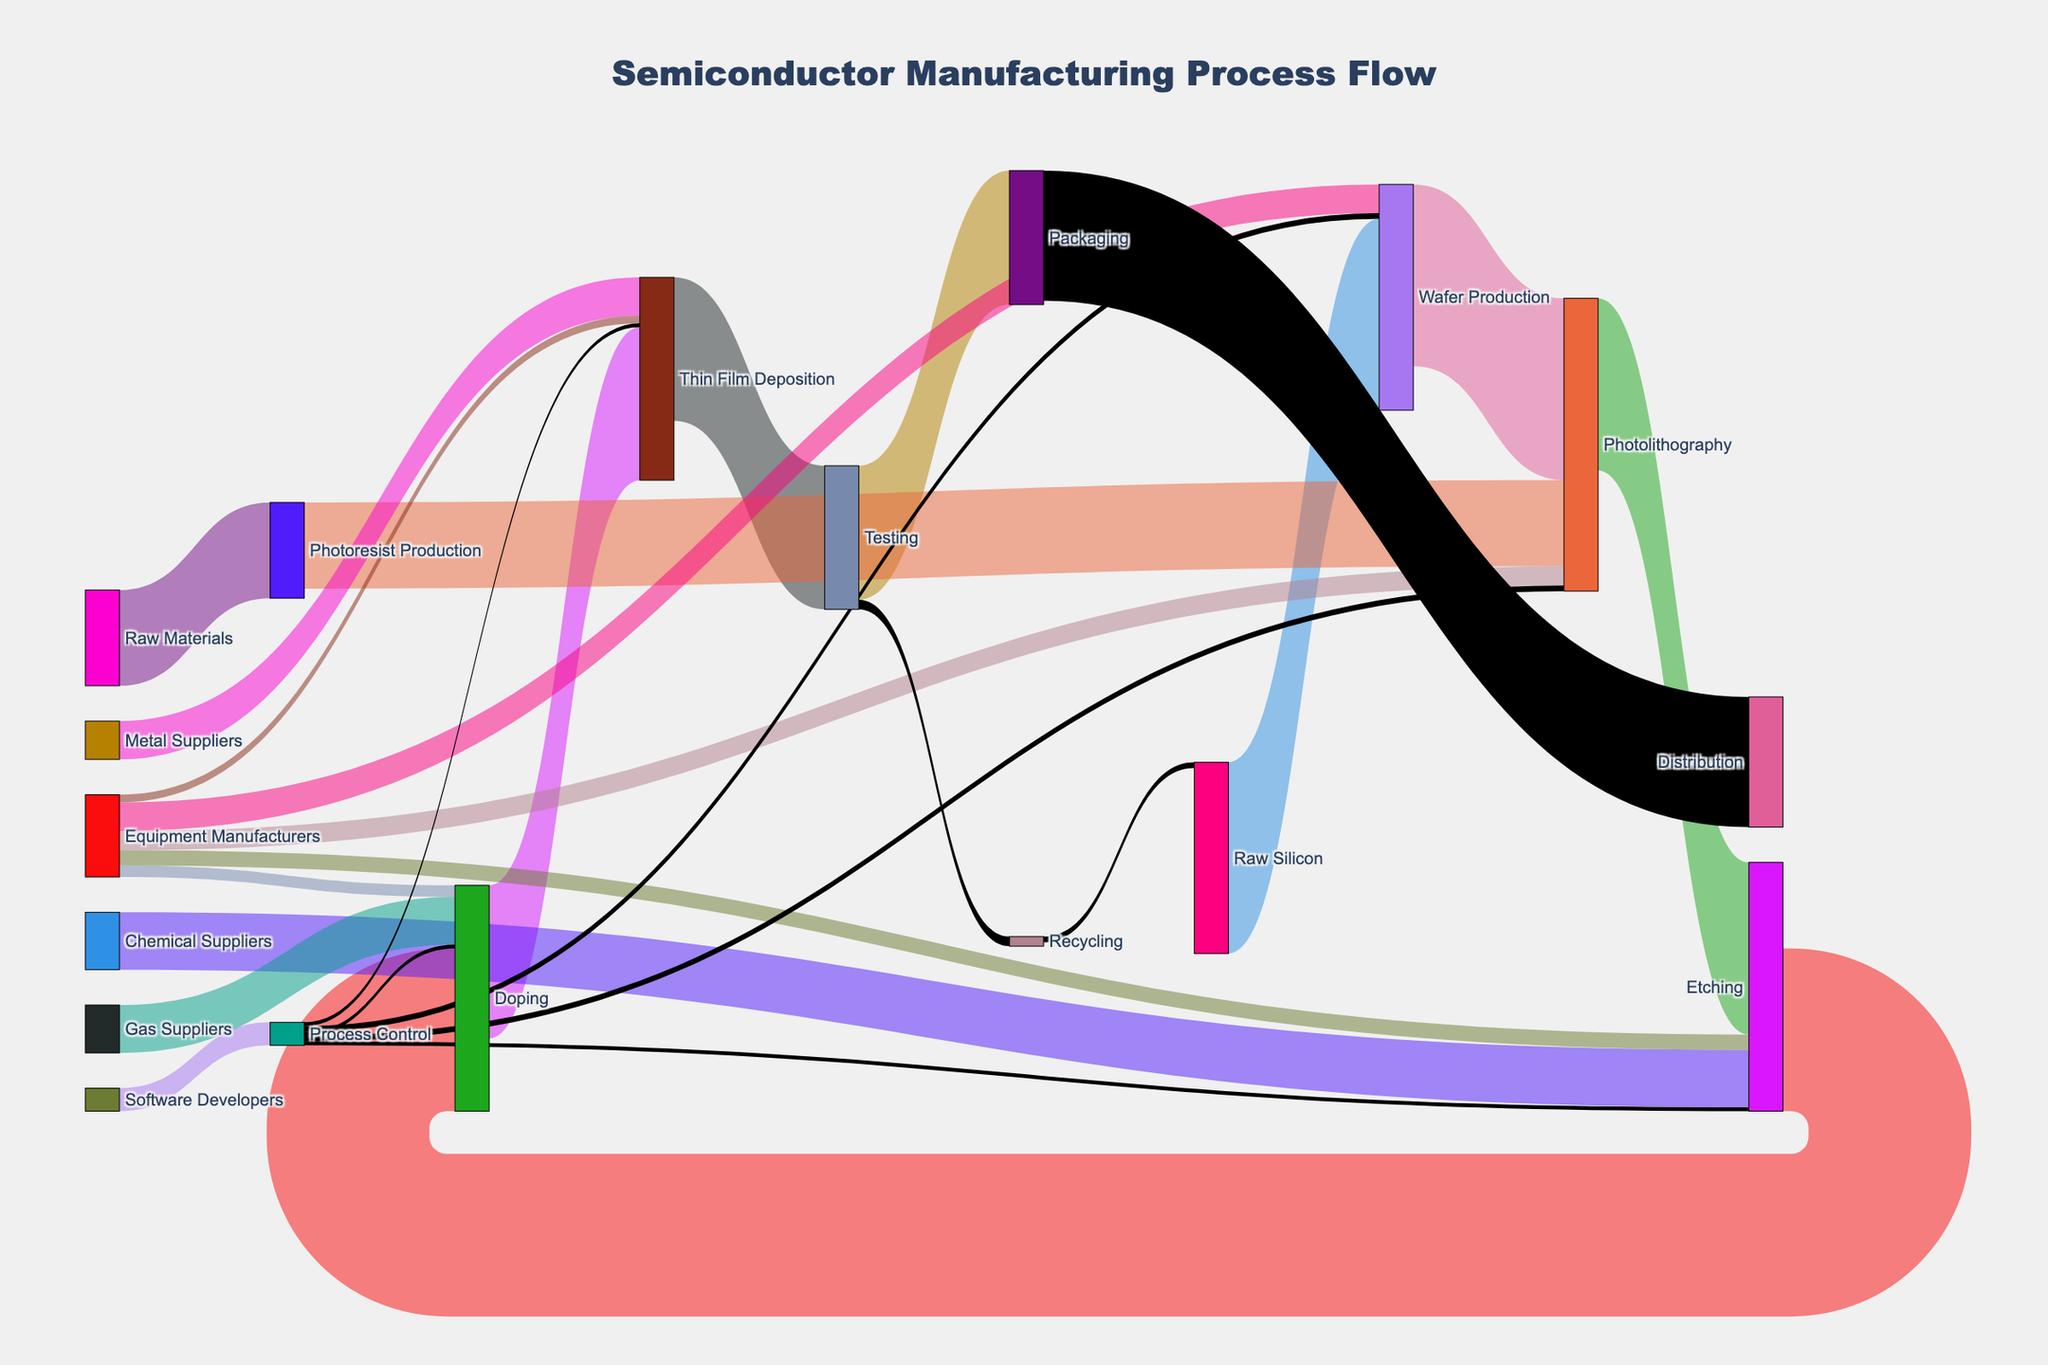What is the title of the Sankey Diagram? The diagram's title is often at the top and includes the subject matter. The title for this Sankey Diagram is provided in the code.
Answer: Semiconductor Manufacturing Process Flow Which node has the highest initial value? The node with the highest initial value is identified by the greatest number in the dataset's 'value' column under the 'source' category. The value 100 is associated with 'Raw Silicon'.
Answer: Raw Silicon How many paths lead directly from Equipment Manufacturers? Count the number of connections, or 'links', that start from 'Equipment Manufacturers' in the source column. There are links to Wafer Production, Photolithography, Etching, Doping, and Thin Film Deposition, so there are 5 paths.
Answer: 5 What is the final destination for the majority of the components? Look for the 'target' nodes without subsequent sources. Packaging is the major destination with a final flow value of 70, followed by Distribution with 68.
Answer: Packaging What is the total flow value through Photolithography? Sum up all inflows and outflows from the Photolithography node: Inflows: Wafer Production (95), Photoresist Production (45), Equipment Manufacturers (10), Process Control (3); Outflows: Etching (90). Total inflow (95 + 45 + 10 + 3 = 153).
Answer: 153 What is the flow value difference between Wafer Production and Thin Film Deposition? The flow value of Wafer Production is 95 (to Photolithography) + 3 (to Process Control) which totals 98. The flow value of Thin Film Deposition is 80 (from Doping) + 4 (from Equipment Manufacturers) + 2 (from Process Control), totaling 86. The difference is 98 - 86.
Answer: 12 Which two suppliers contribute to the Etching process? Find nodes connected to 'Etching' in the target column. Both 'Chemical Suppliers' (value 30) and 'Equipment Manufacturers' (value 8) contribute to Etching.
Answer: Chemical Suppliers and Equipment Manufacturers Which node has the least number of different connections? Search for the node with the minimum distinct links (either as source or target). 'Recycling' with only one connection (to Raw Silicon) has the least.
Answer: Recycling What is the total value of raw materials used in the process? Add the values for Raw Silicon (100) and Raw Materials (50).
Answer: 150 Is the flow value from Chemical Suppliers to Etching greater than the flow value from Gas Suppliers to Doping? Comparing the values from the dataset shows Chemical Suppliers to Etching (30), and Gas Suppliers to Doping (25). 30 is greater than 25.
Answer: Yes 